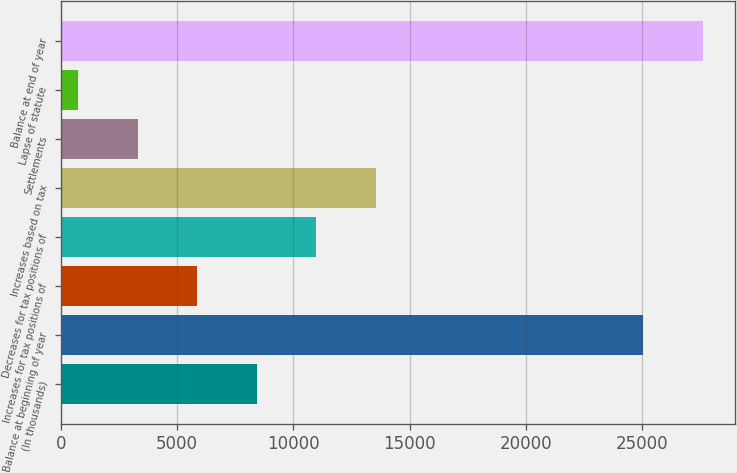Convert chart. <chart><loc_0><loc_0><loc_500><loc_500><bar_chart><fcel>(In thousands)<fcel>Balance at beginning of year<fcel>Increases for tax positions of<fcel>Decreases for tax positions of<fcel>Increases based on tax<fcel>Settlements<fcel>Lapse of statute<fcel>Balance at end of year<nl><fcel>8420.5<fcel>25059<fcel>5862<fcel>10979<fcel>13537.5<fcel>3303.5<fcel>745<fcel>27617.5<nl></chart> 